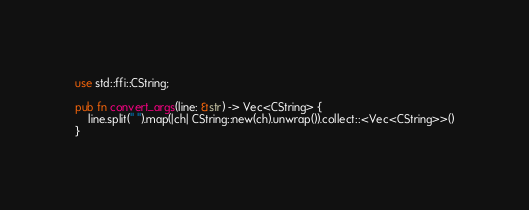<code> <loc_0><loc_0><loc_500><loc_500><_Rust_>use std::ffi::CString;

pub fn convert_args(line: &str) -> Vec<CString> {
	line.split(" ").map(|ch| CString::new(ch).unwrap()).collect::<Vec<CString>>()
}
</code> 